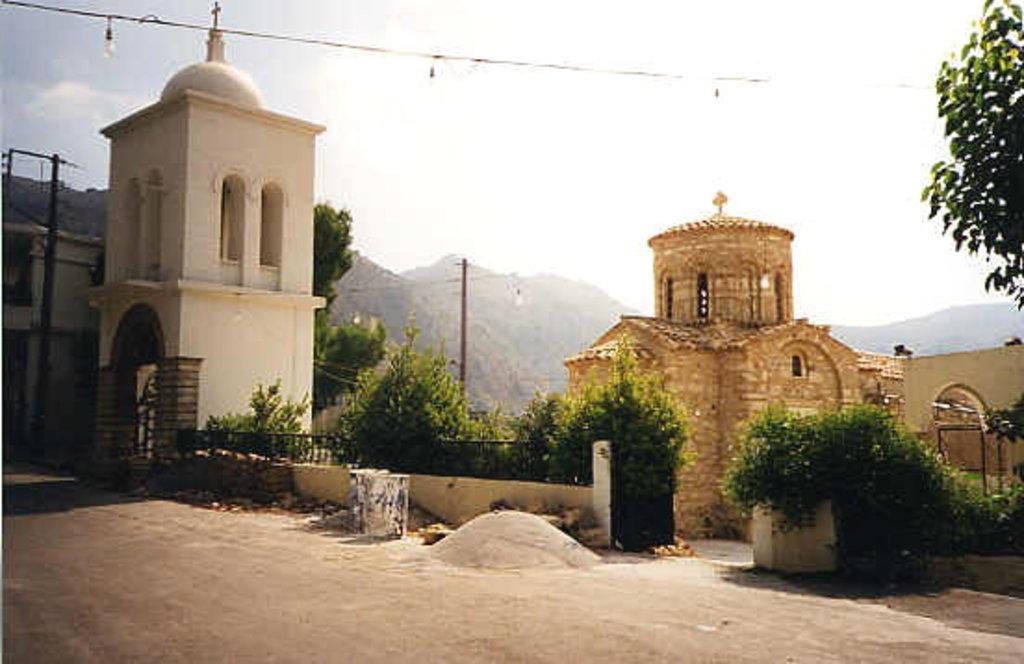Could you give a brief overview of what you see in this image? In this image, we can see buildings, plants, railings, road, walkway, trees, poles, wires and few objects. Background we can see hills and sky. 